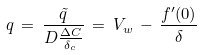<formula> <loc_0><loc_0><loc_500><loc_500>q \, = \, \frac { \tilde { q } } { D \frac { \Delta C } { \delta _ { c } } } \, = \, V _ { w } \, - \, \frac { f ^ { \prime } ( 0 ) } { \delta }</formula> 